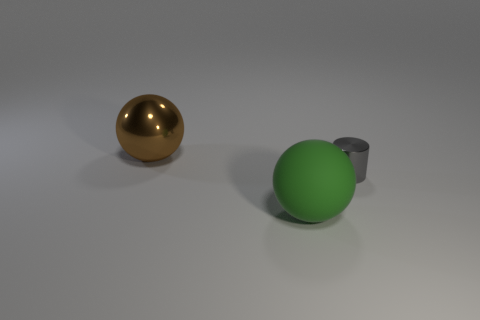Is there any other thing that is the same material as the green ball?
Make the answer very short. No. There is a object that is both behind the green rubber ball and in front of the metallic sphere; what color is it?
Your answer should be very brief. Gray. Is the shape of the big object in front of the large brown metallic ball the same as the object that is left of the rubber object?
Offer a terse response. Yes. What is the large object that is behind the small gray object made of?
Make the answer very short. Metal. How many things are either things on the right side of the big brown ball or brown balls?
Give a very brief answer. 3. Is the number of gray shiny cylinders in front of the small gray cylinder the same as the number of rubber things?
Offer a terse response. No. Does the gray object have the same size as the rubber object?
Make the answer very short. No. The other shiny thing that is the same size as the green object is what color?
Your answer should be very brief. Brown. There is a rubber ball; is it the same size as the object on the left side of the big green ball?
Provide a succinct answer. Yes. How many big spheres are the same color as the tiny shiny thing?
Give a very brief answer. 0. 